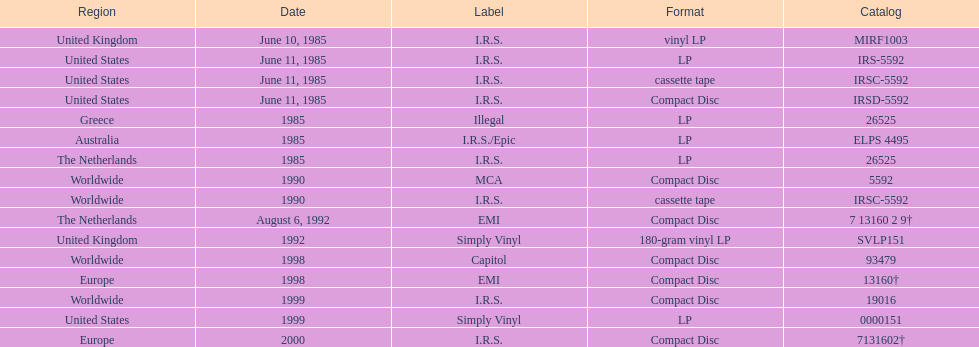Would you mind parsing the complete table? {'header': ['Region', 'Date', 'Label', 'Format', 'Catalog'], 'rows': [['United Kingdom', 'June 10, 1985', 'I.R.S.', 'vinyl LP', 'MIRF1003'], ['United States', 'June 11, 1985', 'I.R.S.', 'LP', 'IRS-5592'], ['United States', 'June 11, 1985', 'I.R.S.', 'cassette tape', 'IRSC-5592'], ['United States', 'June 11, 1985', 'I.R.S.', 'Compact Disc', 'IRSD-5592'], ['Greece', '1985', 'Illegal', 'LP', '26525'], ['Australia', '1985', 'I.R.S./Epic', 'LP', 'ELPS 4495'], ['The Netherlands', '1985', 'I.R.S.', 'LP', '26525'], ['Worldwide', '1990', 'MCA', 'Compact Disc', '5592'], ['Worldwide', '1990', 'I.R.S.', 'cassette tape', 'IRSC-5592'], ['The Netherlands', 'August 6, 1992', 'EMI', 'Compact Disc', '7 13160 2 9†'], ['United Kingdom', '1992', 'Simply Vinyl', '180-gram vinyl LP', 'SVLP151'], ['Worldwide', '1998', 'Capitol', 'Compact Disc', '93479'], ['Europe', '1998', 'EMI', 'Compact Disc', '13160†'], ['Worldwide', '1999', 'I.R.S.', 'Compact Disc', '19016'], ['United States', '1999', 'Simply Vinyl', 'LP', '0000151'], ['Europe', '2000', 'I.R.S.', 'Compact Disc', '7131602†']]} Name at least two labels that released the group's albums. I.R.S., Illegal. 